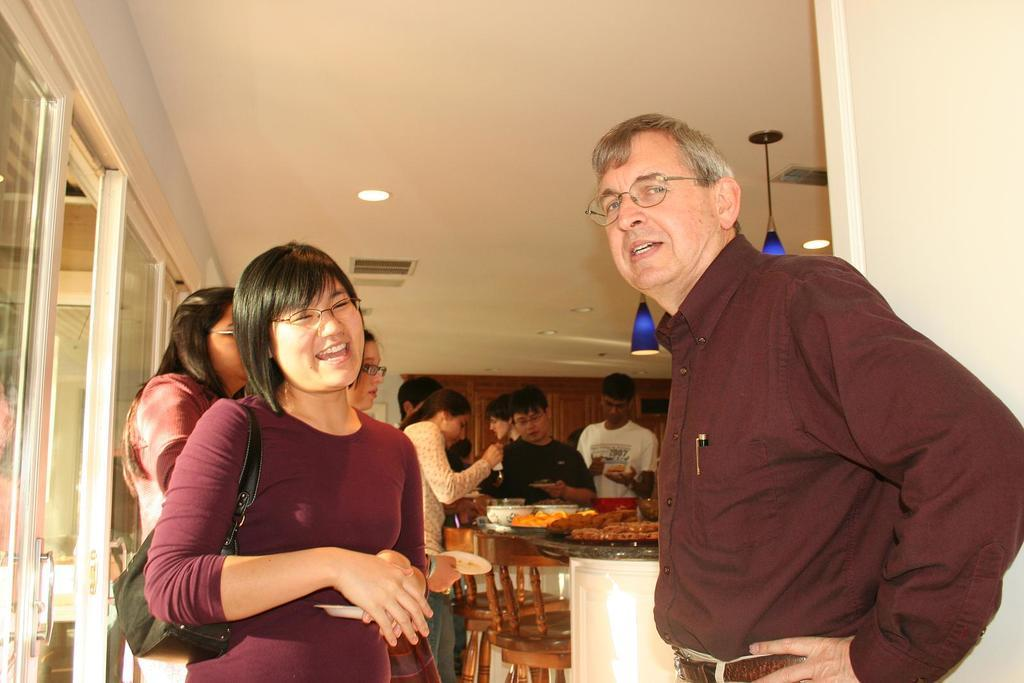What is happening in the image? There are people around a table in the image. How many people are around the table? The number of people around the table is not specified, but there are two people beside the table. What might the people around the table be doing? It is not clear from the image what the people around the table are doing, but they could be eating, playing a game, or engaging in conversation. How many clams are on the table in the image? There is no mention of clams in the image, so it is not possible to answer this question. 